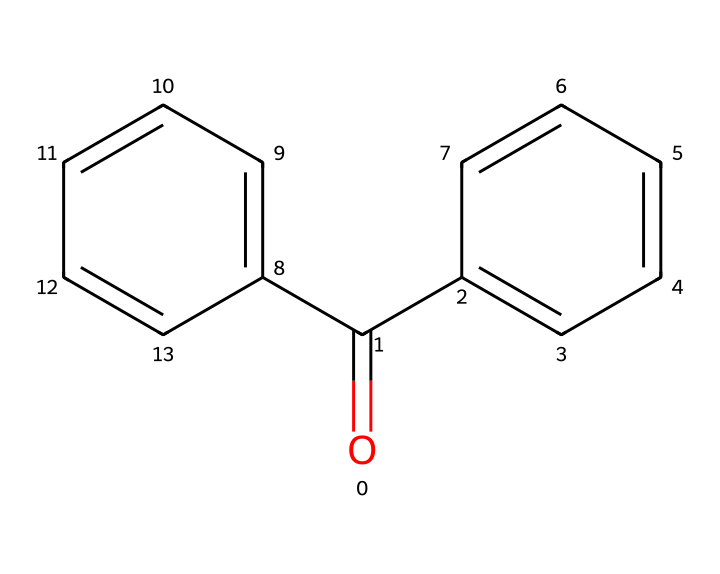What is the name of this chemical? The SMILES structure provided corresponds to benzophenone, which is identified by the arrangement of carbonyl (C=O) and phenyl groups (aromatic rings).
Answer: benzophenone How many carbon atoms are in this molecule? By analyzing the SMILES representation, we count a total of 13 carbon atoms, including those in the two phenyl groups and the carbonyl carbon.
Answer: 13 What type of functional group is present in benzophenone? The molecule features a carbonyl group (C=O), which is characteristic of ketones and is a crucial feature in the classification of this compound.
Answer: carbonyl What is the molecular weight of benzophenone? The molecular weight can be calculated based on the atomic weights of the constituent atoms: 13 carbons, 10 hydrogens, and 1 oxygen, totaling approximately 182.24 g/mol.
Answer: 182.24 Does benzophenone have UV-absorbing properties? Yes, benzophenone is known for its ability to absorb UV radiation, which is why it is commonly included in high-end sunscreens to protect the skin from UV damage.
Answer: yes What aromatic structure does benzophenone contain? The structure includes two phenyl rings, which are integral parts of its molecular composition, contributing to its aromatic character.
Answer: phenyl rings 